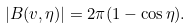<formula> <loc_0><loc_0><loc_500><loc_500>| B ( v , \eta ) | = 2 \pi ( 1 - \cos \eta ) .</formula> 